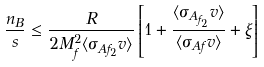Convert formula to latex. <formula><loc_0><loc_0><loc_500><loc_500>\frac { n _ { B } } { s } \leq \frac { R } { 2 M ^ { 2 } _ { f } \langle \sigma _ { A f _ { 2 } } v \rangle } \left [ 1 + \frac { \langle \sigma _ { A _ { f _ { 2 } } } v \rangle } { \langle \sigma _ { A f } v \rangle } + \xi \right ]</formula> 